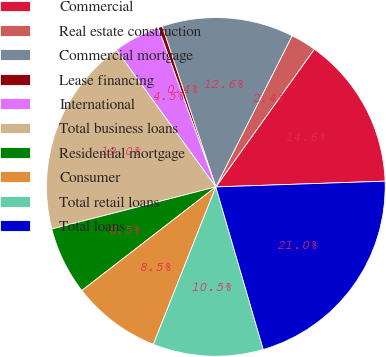Convert chart. <chart><loc_0><loc_0><loc_500><loc_500><pie_chart><fcel>Commercial<fcel>Real estate construction<fcel>Commercial mortgage<fcel>Lease financing<fcel>International<fcel>Total business loans<fcel>Residential mortgage<fcel>Consumer<fcel>Total retail loans<fcel>Total loans<nl><fcel>14.58%<fcel>2.44%<fcel>12.56%<fcel>0.41%<fcel>4.46%<fcel>19.0%<fcel>6.48%<fcel>8.51%<fcel>10.53%<fcel>21.02%<nl></chart> 